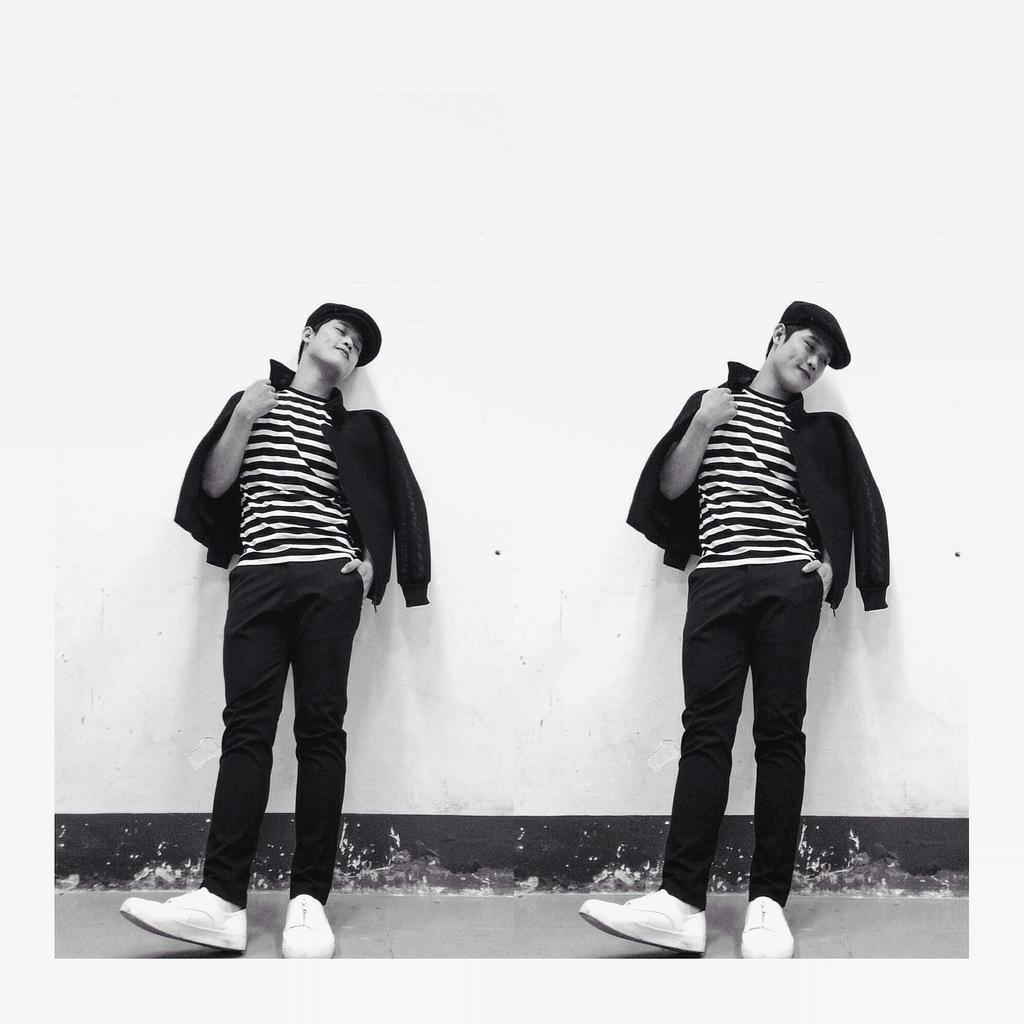What is the color scheme of the image? The image is black and white. How many people are in the foreground of the image? There are two persons in the foreground of the image. What are the persons wearing on their heads? The persons are wearing hats. What type of clothing are the persons wearing on their upper bodies? The persons are wearing jackets. What are the persons doing in the image? The persons are leaning on a wall. What is the color of the wall the persons are leaning on? The wall is painted white. Can you tell me how many twigs are being used to make a pie in the image? There are no twigs or pies present in the image; it features two persons wearing hats and jackets, leaning on a white wall. 